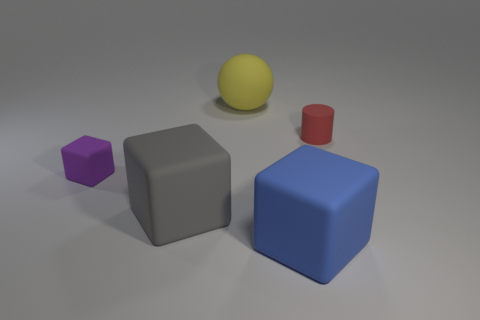Subtract 1 cubes. How many cubes are left? 2 Add 2 big green rubber things. How many objects exist? 7 Subtract all blocks. How many objects are left? 2 Add 2 small matte things. How many small matte things are left? 4 Add 3 blue matte objects. How many blue matte objects exist? 4 Subtract 0 brown spheres. How many objects are left? 5 Subtract all big blue blocks. Subtract all purple matte things. How many objects are left? 3 